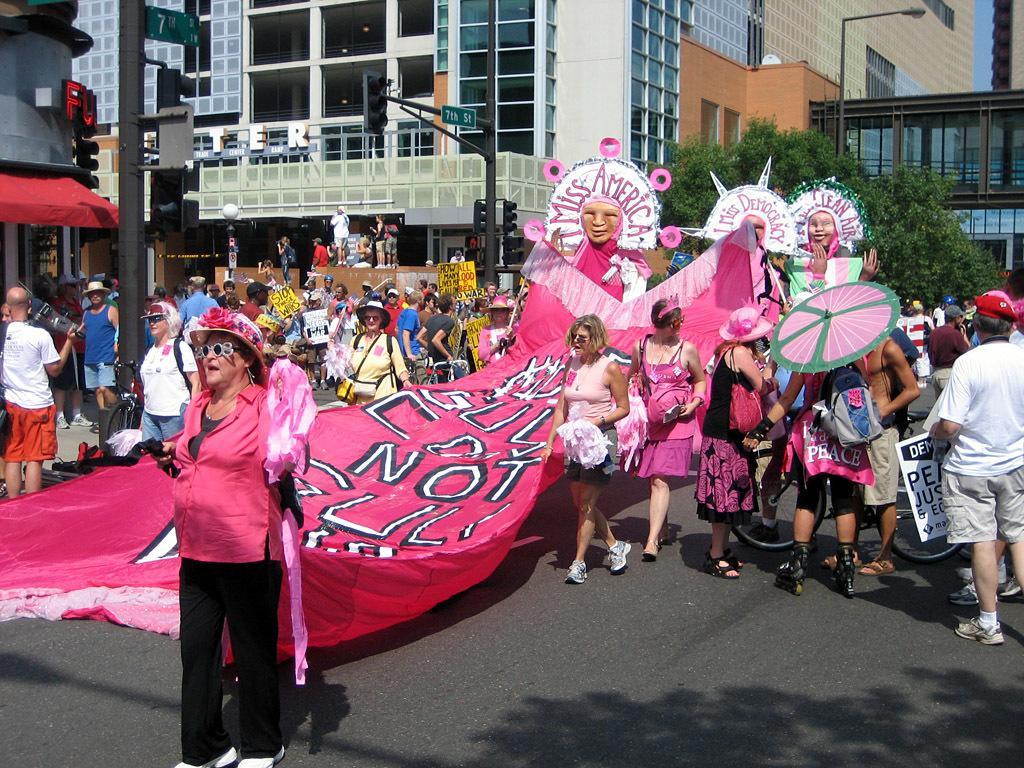In one or two sentences, can you explain what this image depicts? In this image I can see group of people some are standing and some are walking. I can also see a pink color banner, background I can see few statues, traffic signals, buildings in white, brown and cream color and I can also see few stalls. 